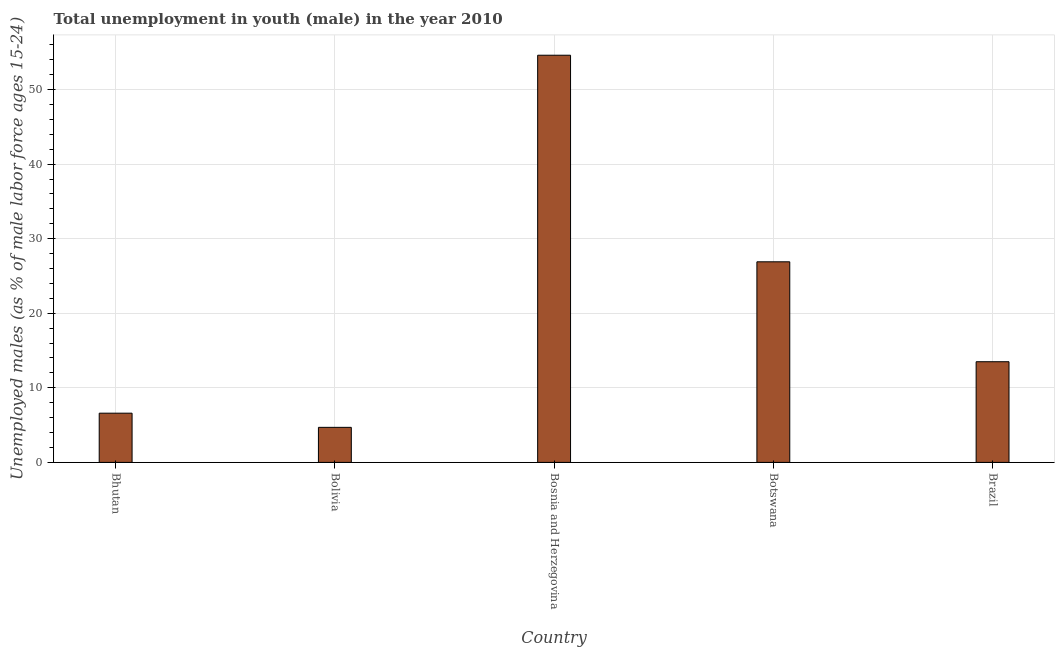Does the graph contain any zero values?
Give a very brief answer. No. What is the title of the graph?
Your answer should be very brief. Total unemployment in youth (male) in the year 2010. What is the label or title of the X-axis?
Your answer should be very brief. Country. What is the label or title of the Y-axis?
Give a very brief answer. Unemployed males (as % of male labor force ages 15-24). What is the unemployed male youth population in Bosnia and Herzegovina?
Offer a very short reply. 54.6. Across all countries, what is the maximum unemployed male youth population?
Provide a short and direct response. 54.6. Across all countries, what is the minimum unemployed male youth population?
Give a very brief answer. 4.7. In which country was the unemployed male youth population maximum?
Keep it short and to the point. Bosnia and Herzegovina. What is the sum of the unemployed male youth population?
Offer a terse response. 106.3. What is the difference between the unemployed male youth population in Bhutan and Bolivia?
Give a very brief answer. 1.9. What is the average unemployed male youth population per country?
Make the answer very short. 21.26. What is the median unemployed male youth population?
Offer a very short reply. 13.5. What is the ratio of the unemployed male youth population in Botswana to that in Brazil?
Your answer should be very brief. 1.99. Is the unemployed male youth population in Bhutan less than that in Brazil?
Ensure brevity in your answer.  Yes. Is the difference between the unemployed male youth population in Bhutan and Brazil greater than the difference between any two countries?
Your answer should be compact. No. What is the difference between the highest and the second highest unemployed male youth population?
Keep it short and to the point. 27.7. Is the sum of the unemployed male youth population in Botswana and Brazil greater than the maximum unemployed male youth population across all countries?
Keep it short and to the point. No. What is the difference between the highest and the lowest unemployed male youth population?
Offer a very short reply. 49.9. Are all the bars in the graph horizontal?
Provide a succinct answer. No. What is the difference between two consecutive major ticks on the Y-axis?
Keep it short and to the point. 10. What is the Unemployed males (as % of male labor force ages 15-24) of Bhutan?
Give a very brief answer. 6.6. What is the Unemployed males (as % of male labor force ages 15-24) in Bolivia?
Your response must be concise. 4.7. What is the Unemployed males (as % of male labor force ages 15-24) of Bosnia and Herzegovina?
Provide a short and direct response. 54.6. What is the Unemployed males (as % of male labor force ages 15-24) of Botswana?
Give a very brief answer. 26.9. What is the Unemployed males (as % of male labor force ages 15-24) in Brazil?
Offer a terse response. 13.5. What is the difference between the Unemployed males (as % of male labor force ages 15-24) in Bhutan and Bolivia?
Offer a very short reply. 1.9. What is the difference between the Unemployed males (as % of male labor force ages 15-24) in Bhutan and Bosnia and Herzegovina?
Give a very brief answer. -48. What is the difference between the Unemployed males (as % of male labor force ages 15-24) in Bhutan and Botswana?
Offer a terse response. -20.3. What is the difference between the Unemployed males (as % of male labor force ages 15-24) in Bolivia and Bosnia and Herzegovina?
Provide a succinct answer. -49.9. What is the difference between the Unemployed males (as % of male labor force ages 15-24) in Bolivia and Botswana?
Your answer should be compact. -22.2. What is the difference between the Unemployed males (as % of male labor force ages 15-24) in Bolivia and Brazil?
Provide a succinct answer. -8.8. What is the difference between the Unemployed males (as % of male labor force ages 15-24) in Bosnia and Herzegovina and Botswana?
Keep it short and to the point. 27.7. What is the difference between the Unemployed males (as % of male labor force ages 15-24) in Bosnia and Herzegovina and Brazil?
Make the answer very short. 41.1. What is the ratio of the Unemployed males (as % of male labor force ages 15-24) in Bhutan to that in Bolivia?
Your response must be concise. 1.4. What is the ratio of the Unemployed males (as % of male labor force ages 15-24) in Bhutan to that in Bosnia and Herzegovina?
Your answer should be compact. 0.12. What is the ratio of the Unemployed males (as % of male labor force ages 15-24) in Bhutan to that in Botswana?
Ensure brevity in your answer.  0.24. What is the ratio of the Unemployed males (as % of male labor force ages 15-24) in Bhutan to that in Brazil?
Keep it short and to the point. 0.49. What is the ratio of the Unemployed males (as % of male labor force ages 15-24) in Bolivia to that in Bosnia and Herzegovina?
Make the answer very short. 0.09. What is the ratio of the Unemployed males (as % of male labor force ages 15-24) in Bolivia to that in Botswana?
Provide a short and direct response. 0.17. What is the ratio of the Unemployed males (as % of male labor force ages 15-24) in Bolivia to that in Brazil?
Offer a terse response. 0.35. What is the ratio of the Unemployed males (as % of male labor force ages 15-24) in Bosnia and Herzegovina to that in Botswana?
Provide a short and direct response. 2.03. What is the ratio of the Unemployed males (as % of male labor force ages 15-24) in Bosnia and Herzegovina to that in Brazil?
Give a very brief answer. 4.04. What is the ratio of the Unemployed males (as % of male labor force ages 15-24) in Botswana to that in Brazil?
Your response must be concise. 1.99. 